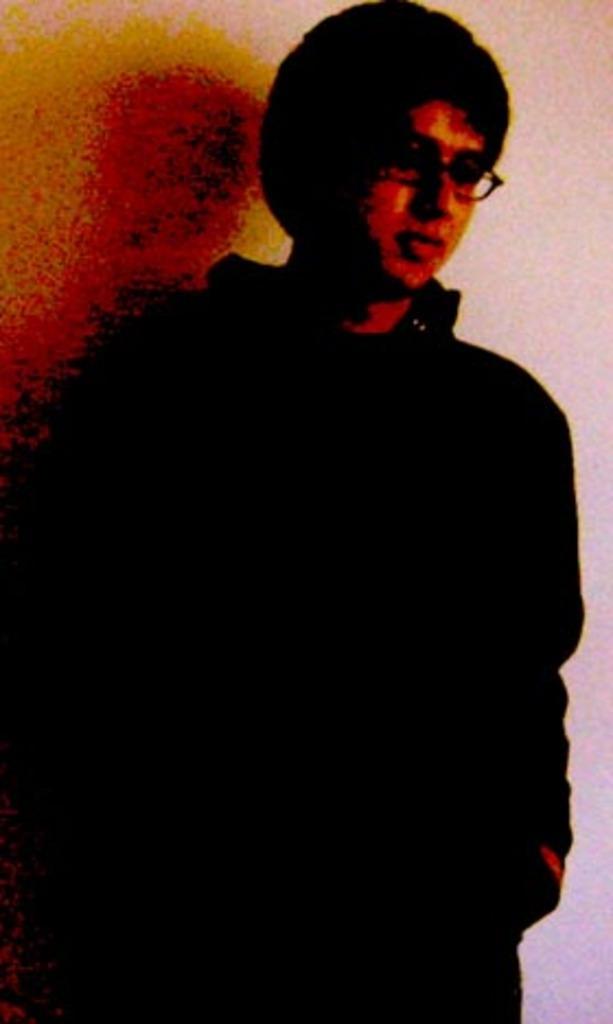Can you describe this image briefly? In this image I can see a person is looking at the right side, this person is wearing the spectacles. 